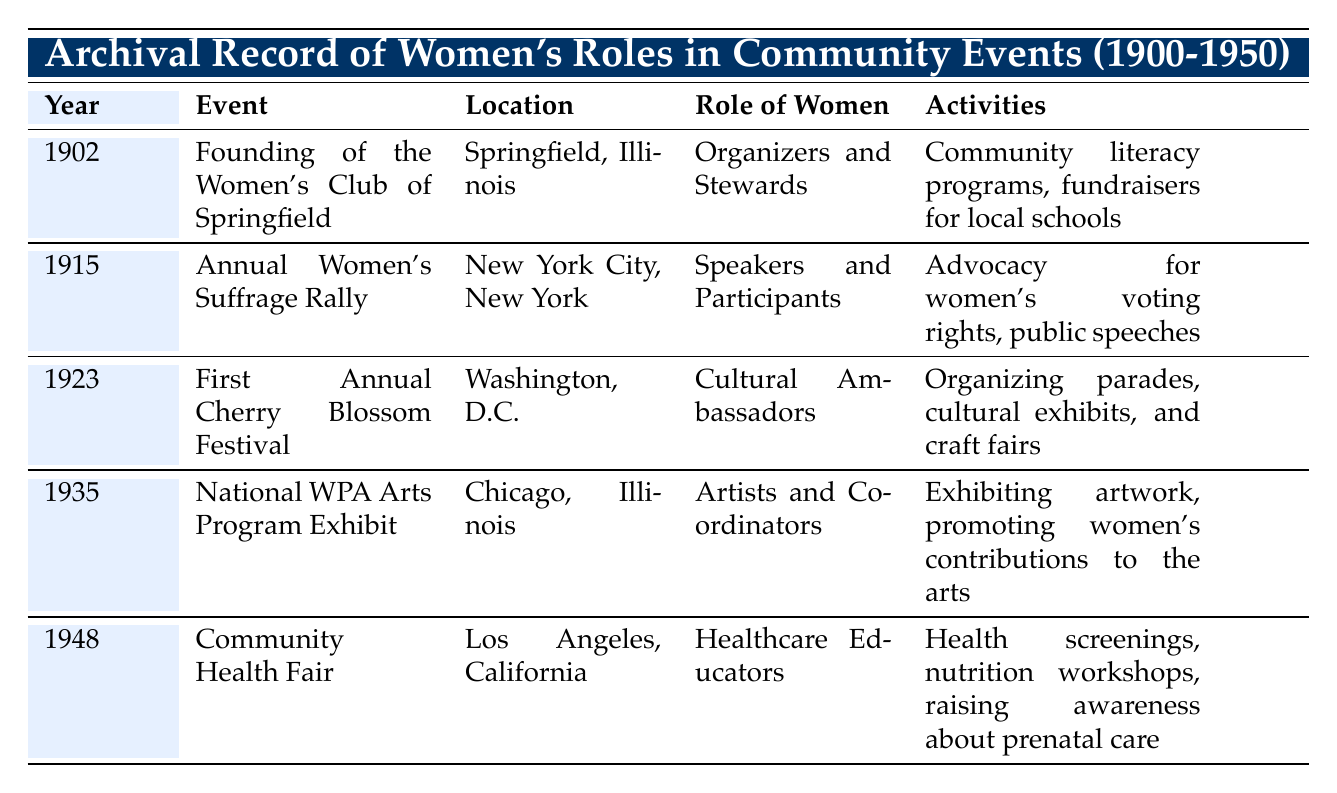What year did the Women's Club of Springfield get founded? The table lists the events chronologically, and the first event is for the year 1902, which is the founding of the Women's Club of Springfield.
Answer: 1902 Which event took place in New York City? Referring to the table, the Annual Women's Suffrage Rally, occurring in 1915, is the event specified as taking place in New York City.
Answer: Annual Women's Suffrage Rally Did women act as healthcare educators in community events before 1948? By examining the table, the only event where women are noted as healthcare educators is in 1948; therefore, it is evident that there are no records of women in this role before that year.
Answer: No What activities were associated with the First Annual Cherry Blossom Festival? The table indicates that the activities associated with the event in 1923 included organizing parades, cultural exhibits, and craft fairs.
Answer: Organizing parades, cultural exhibits, and craft fairs Which role did women have at the National WPA Arts Program Exhibit? From the table, it is clear that during the National WPA Arts Program Exhibit in 1935, women served as artists and coordinators, showcasing their contributions to the arts.
Answer: Artists and Coordinators How many events are recorded where women organized activities? The table shows two events: the founding of the Women's Club of Springfield in 1902 and the First Annual Cherry Blossom Festival in 1923, where women were explicitly involved in organizing activities. Thus, the total is two events.
Answer: Two events What was the difference in years between the Annual Women's Suffrage Rally and the Community Health Fair? The Annual Women's Suffrage Rally occurred in 1915 and the Community Health Fair in 1948. To find the difference, subtract 1915 from 1948, resulting in 33 years.
Answer: 33 years Were women involved in promoting arts before 1948? Referring to the table, it shows that women highlighted their contributions to the arts at the National WPA Arts Program Exhibit in 1935; therefore, it can be confirmed that they were involved in promoting arts before 1948.
Answer: Yes In which location did the Community Health Fair take place? According to the table, the Community Health Fair took place in Los Angeles, California, as indicated in the location column for that entry.
Answer: Los Angeles, California 